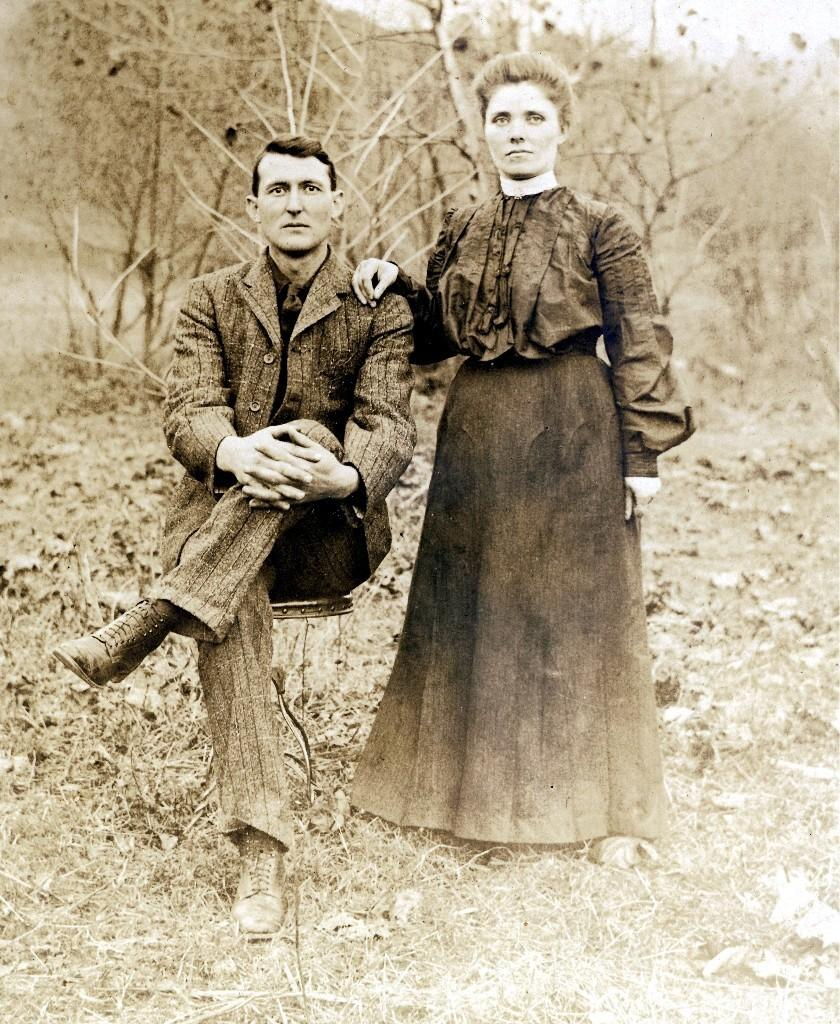What are the people in the image doing? The persons in the image are standing and sitting in the front. What is the ground covered with in the image? Dry grass is present on the ground. What can be seen in the background of the image? There are dry trees in the background. What is the rate of the notebook in the image? There is no notebook present in the image, so it is not possible to determine a rate. 